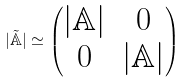<formula> <loc_0><loc_0><loc_500><loc_500>| \tilde { { \mathbb { A } } } | \simeq \begin{pmatrix} | { \mathbb { A } } | & 0 \\ 0 & | { \mathbb { A } } | \end{pmatrix}</formula> 